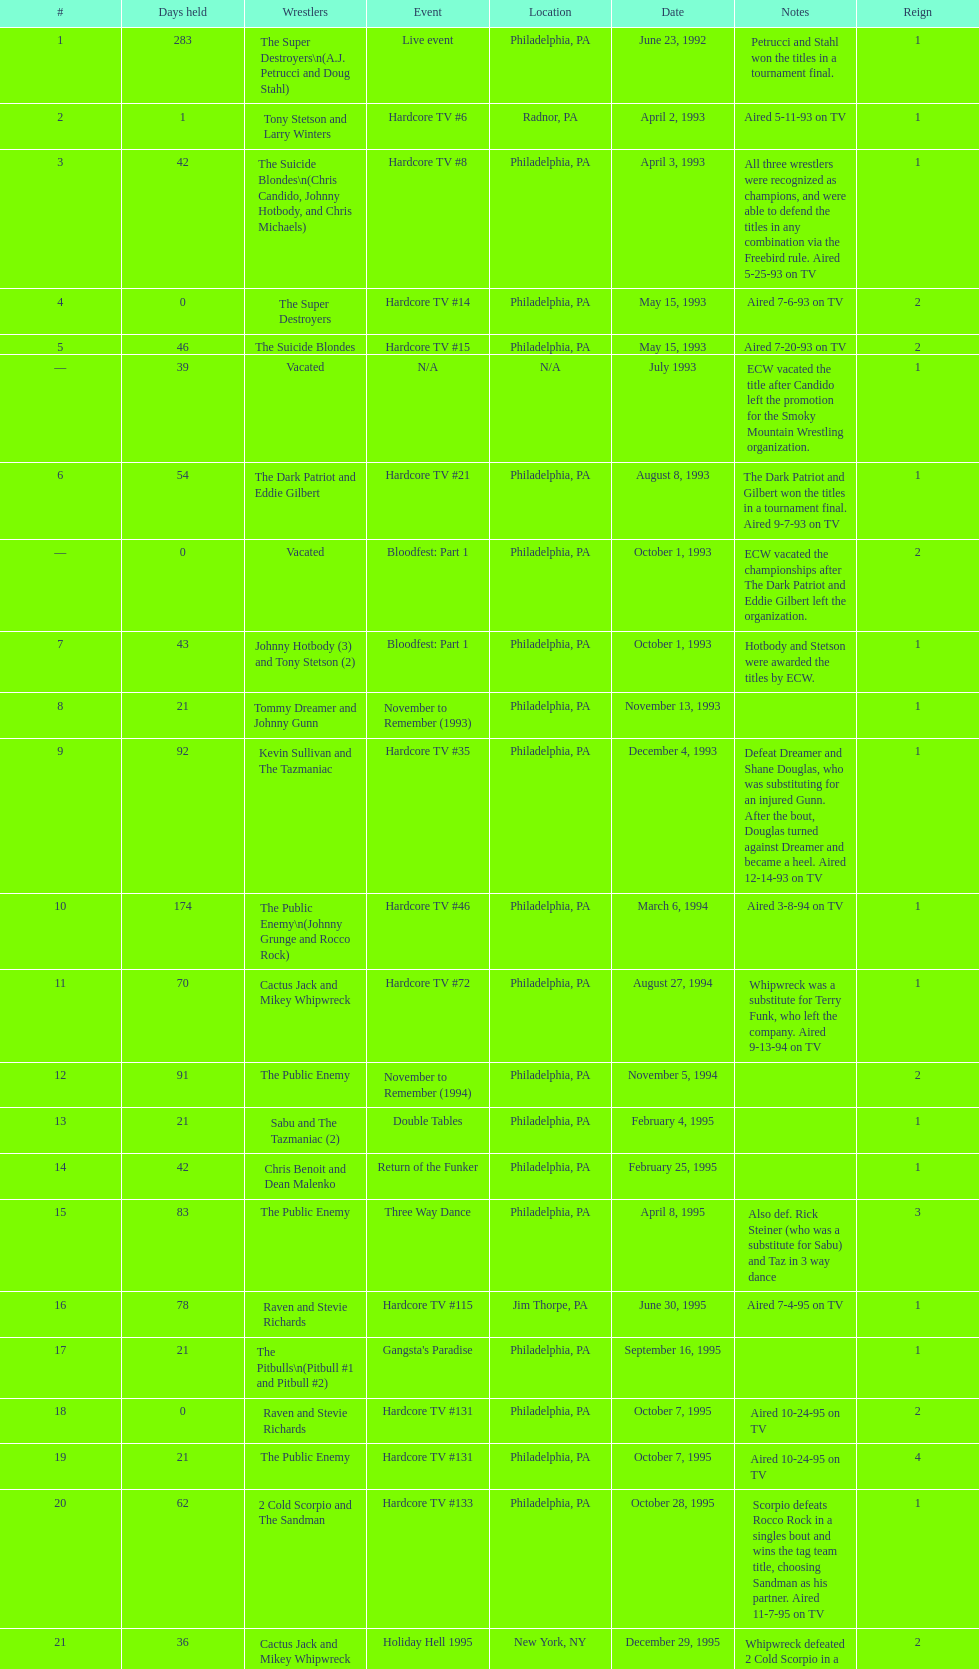What is the total days held on # 1st? 283. 